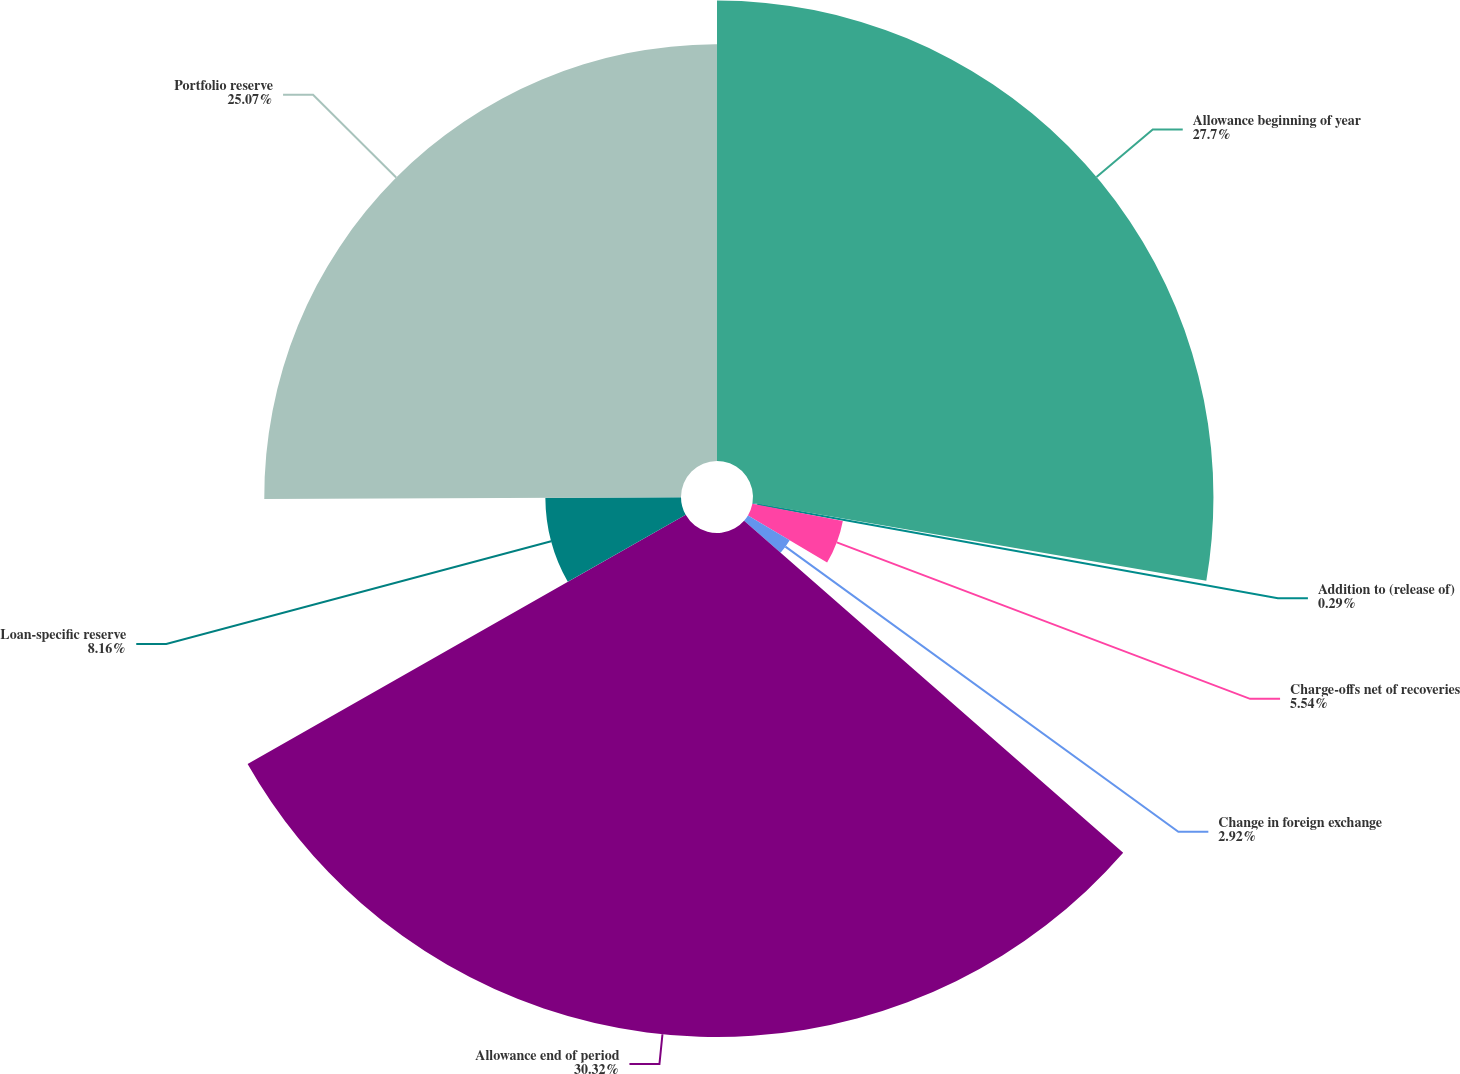Convert chart to OTSL. <chart><loc_0><loc_0><loc_500><loc_500><pie_chart><fcel>Allowance beginning of year<fcel>Addition to (release of)<fcel>Charge-offs net of recoveries<fcel>Change in foreign exchange<fcel>Allowance end of period<fcel>Loan-specific reserve<fcel>Portfolio reserve<nl><fcel>27.7%<fcel>0.29%<fcel>5.54%<fcel>2.92%<fcel>30.32%<fcel>8.16%<fcel>25.07%<nl></chart> 